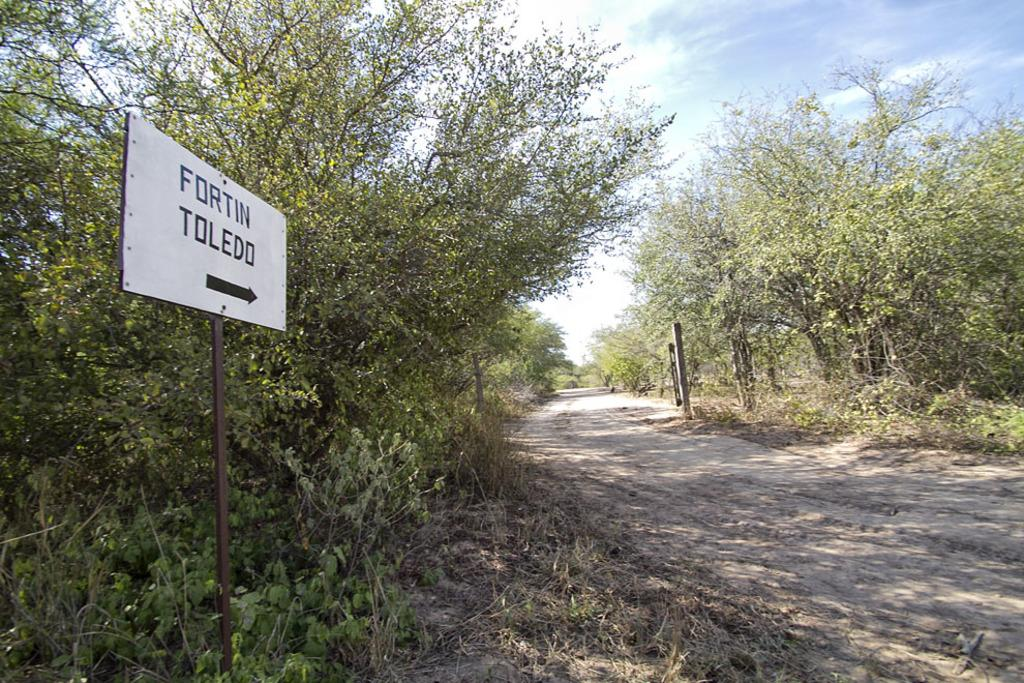What is the main feature of the image? There is a road in the image. What can be seen on the left side of the image? There is a board and trees on the left side of the image. What is visible at the top of the image? The sky is visible at the top of the image. Are there any trees present in the image? Yes, there are trees on both the left and right sides of the image. What is the ground cover at the bottom of the image? Dry grass is present at the bottom of the image. Where is the lunchroom located in the image? There is no lunchroom present in the image. What type of root can be seen growing near the trees in the image? There are no roots visible in the image; only trees and dry grass are present. 